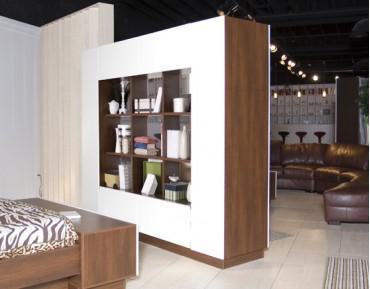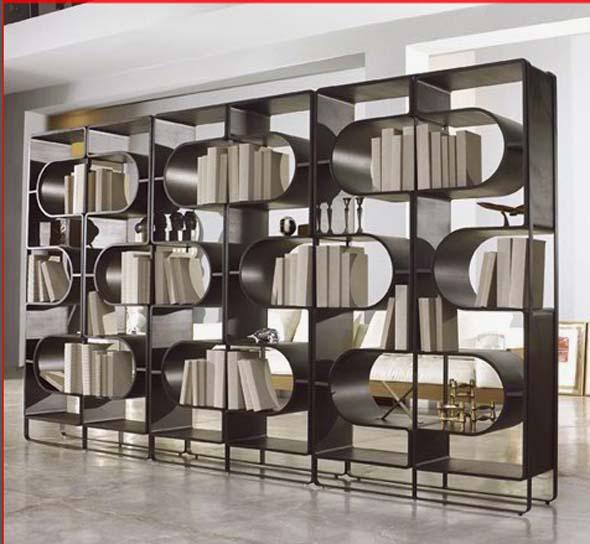The first image is the image on the left, the second image is the image on the right. For the images shown, is this caption "In one image a large room-dividing shelf unit is placed near the foot of a bed." true? Answer yes or no. Yes. The first image is the image on the left, the second image is the image on the right. Considering the images on both sides, is "A white bookcase separates a bed from the rest of the living space." valid? Answer yes or no. Yes. 